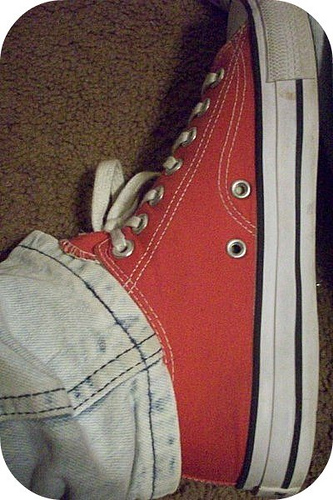<image>
Is the shoe to the right of the jeans? Yes. From this viewpoint, the shoe is positioned to the right side relative to the jeans. 